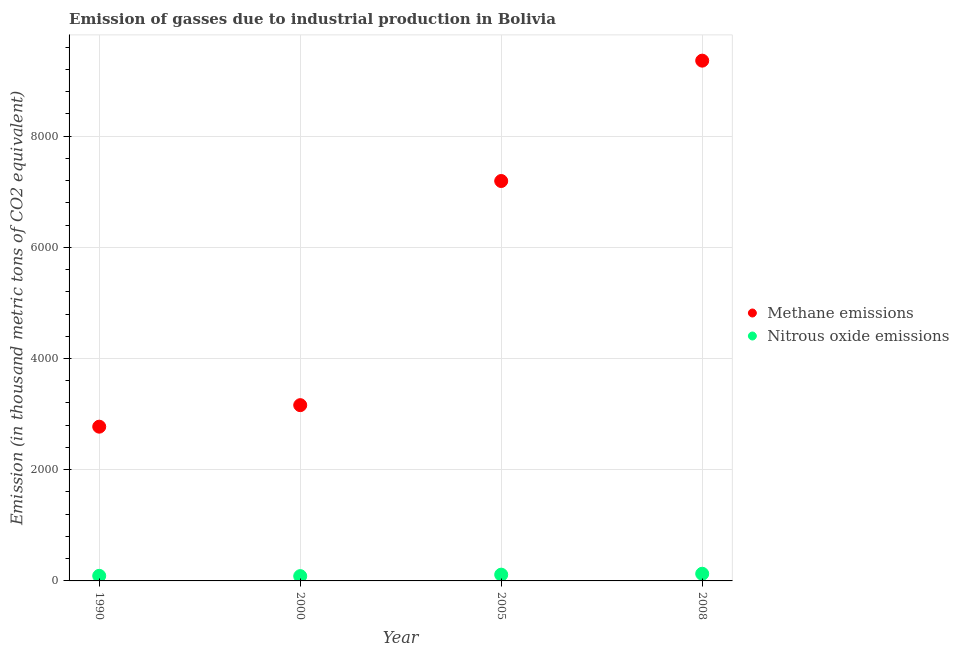What is the amount of methane emissions in 2008?
Provide a short and direct response. 9356.3. Across all years, what is the maximum amount of methane emissions?
Provide a short and direct response. 9356.3. Across all years, what is the minimum amount of methane emissions?
Your answer should be compact. 2773.8. What is the total amount of methane emissions in the graph?
Keep it short and to the point. 2.25e+04. What is the difference between the amount of methane emissions in 1990 and that in 2000?
Provide a succinct answer. -387.1. What is the difference between the amount of nitrous oxide emissions in 2008 and the amount of methane emissions in 2005?
Your response must be concise. -7062.8. What is the average amount of methane emissions per year?
Offer a very short reply. 5620.68. In the year 2005, what is the difference between the amount of methane emissions and amount of nitrous oxide emissions?
Give a very brief answer. 7079. What is the ratio of the amount of methane emissions in 1990 to that in 2008?
Provide a short and direct response. 0.3. Is the difference between the amount of nitrous oxide emissions in 1990 and 2008 greater than the difference between the amount of methane emissions in 1990 and 2008?
Your answer should be very brief. Yes. What is the difference between the highest and the second highest amount of methane emissions?
Provide a succinct answer. 2164.6. What is the difference between the highest and the lowest amount of methane emissions?
Provide a short and direct response. 6582.5. In how many years, is the amount of methane emissions greater than the average amount of methane emissions taken over all years?
Your response must be concise. 2. Is the sum of the amount of methane emissions in 2000 and 2008 greater than the maximum amount of nitrous oxide emissions across all years?
Offer a terse response. Yes. Is the amount of methane emissions strictly greater than the amount of nitrous oxide emissions over the years?
Provide a succinct answer. Yes. Is the amount of methane emissions strictly less than the amount of nitrous oxide emissions over the years?
Provide a succinct answer. No. How many dotlines are there?
Offer a very short reply. 2. What is the difference between two consecutive major ticks on the Y-axis?
Offer a terse response. 2000. What is the title of the graph?
Provide a short and direct response. Emission of gasses due to industrial production in Bolivia. What is the label or title of the X-axis?
Make the answer very short. Year. What is the label or title of the Y-axis?
Your response must be concise. Emission (in thousand metric tons of CO2 equivalent). What is the Emission (in thousand metric tons of CO2 equivalent) in Methane emissions in 1990?
Offer a very short reply. 2773.8. What is the Emission (in thousand metric tons of CO2 equivalent) in Nitrous oxide emissions in 1990?
Your answer should be compact. 91.4. What is the Emission (in thousand metric tons of CO2 equivalent) in Methane emissions in 2000?
Your answer should be very brief. 3160.9. What is the Emission (in thousand metric tons of CO2 equivalent) of Nitrous oxide emissions in 2000?
Your answer should be compact. 86.3. What is the Emission (in thousand metric tons of CO2 equivalent) in Methane emissions in 2005?
Offer a terse response. 7191.7. What is the Emission (in thousand metric tons of CO2 equivalent) in Nitrous oxide emissions in 2005?
Offer a very short reply. 112.7. What is the Emission (in thousand metric tons of CO2 equivalent) of Methane emissions in 2008?
Keep it short and to the point. 9356.3. What is the Emission (in thousand metric tons of CO2 equivalent) in Nitrous oxide emissions in 2008?
Your response must be concise. 128.9. Across all years, what is the maximum Emission (in thousand metric tons of CO2 equivalent) in Methane emissions?
Make the answer very short. 9356.3. Across all years, what is the maximum Emission (in thousand metric tons of CO2 equivalent) in Nitrous oxide emissions?
Your answer should be very brief. 128.9. Across all years, what is the minimum Emission (in thousand metric tons of CO2 equivalent) in Methane emissions?
Offer a terse response. 2773.8. Across all years, what is the minimum Emission (in thousand metric tons of CO2 equivalent) in Nitrous oxide emissions?
Offer a very short reply. 86.3. What is the total Emission (in thousand metric tons of CO2 equivalent) in Methane emissions in the graph?
Provide a succinct answer. 2.25e+04. What is the total Emission (in thousand metric tons of CO2 equivalent) of Nitrous oxide emissions in the graph?
Give a very brief answer. 419.3. What is the difference between the Emission (in thousand metric tons of CO2 equivalent) in Methane emissions in 1990 and that in 2000?
Keep it short and to the point. -387.1. What is the difference between the Emission (in thousand metric tons of CO2 equivalent) in Methane emissions in 1990 and that in 2005?
Your answer should be compact. -4417.9. What is the difference between the Emission (in thousand metric tons of CO2 equivalent) of Nitrous oxide emissions in 1990 and that in 2005?
Make the answer very short. -21.3. What is the difference between the Emission (in thousand metric tons of CO2 equivalent) in Methane emissions in 1990 and that in 2008?
Offer a very short reply. -6582.5. What is the difference between the Emission (in thousand metric tons of CO2 equivalent) of Nitrous oxide emissions in 1990 and that in 2008?
Make the answer very short. -37.5. What is the difference between the Emission (in thousand metric tons of CO2 equivalent) in Methane emissions in 2000 and that in 2005?
Your answer should be very brief. -4030.8. What is the difference between the Emission (in thousand metric tons of CO2 equivalent) of Nitrous oxide emissions in 2000 and that in 2005?
Keep it short and to the point. -26.4. What is the difference between the Emission (in thousand metric tons of CO2 equivalent) in Methane emissions in 2000 and that in 2008?
Offer a very short reply. -6195.4. What is the difference between the Emission (in thousand metric tons of CO2 equivalent) in Nitrous oxide emissions in 2000 and that in 2008?
Offer a terse response. -42.6. What is the difference between the Emission (in thousand metric tons of CO2 equivalent) in Methane emissions in 2005 and that in 2008?
Make the answer very short. -2164.6. What is the difference between the Emission (in thousand metric tons of CO2 equivalent) in Nitrous oxide emissions in 2005 and that in 2008?
Give a very brief answer. -16.2. What is the difference between the Emission (in thousand metric tons of CO2 equivalent) of Methane emissions in 1990 and the Emission (in thousand metric tons of CO2 equivalent) of Nitrous oxide emissions in 2000?
Your answer should be compact. 2687.5. What is the difference between the Emission (in thousand metric tons of CO2 equivalent) in Methane emissions in 1990 and the Emission (in thousand metric tons of CO2 equivalent) in Nitrous oxide emissions in 2005?
Your answer should be very brief. 2661.1. What is the difference between the Emission (in thousand metric tons of CO2 equivalent) of Methane emissions in 1990 and the Emission (in thousand metric tons of CO2 equivalent) of Nitrous oxide emissions in 2008?
Make the answer very short. 2644.9. What is the difference between the Emission (in thousand metric tons of CO2 equivalent) in Methane emissions in 2000 and the Emission (in thousand metric tons of CO2 equivalent) in Nitrous oxide emissions in 2005?
Make the answer very short. 3048.2. What is the difference between the Emission (in thousand metric tons of CO2 equivalent) of Methane emissions in 2000 and the Emission (in thousand metric tons of CO2 equivalent) of Nitrous oxide emissions in 2008?
Keep it short and to the point. 3032. What is the difference between the Emission (in thousand metric tons of CO2 equivalent) in Methane emissions in 2005 and the Emission (in thousand metric tons of CO2 equivalent) in Nitrous oxide emissions in 2008?
Offer a very short reply. 7062.8. What is the average Emission (in thousand metric tons of CO2 equivalent) of Methane emissions per year?
Your answer should be compact. 5620.68. What is the average Emission (in thousand metric tons of CO2 equivalent) of Nitrous oxide emissions per year?
Provide a succinct answer. 104.83. In the year 1990, what is the difference between the Emission (in thousand metric tons of CO2 equivalent) in Methane emissions and Emission (in thousand metric tons of CO2 equivalent) in Nitrous oxide emissions?
Keep it short and to the point. 2682.4. In the year 2000, what is the difference between the Emission (in thousand metric tons of CO2 equivalent) in Methane emissions and Emission (in thousand metric tons of CO2 equivalent) in Nitrous oxide emissions?
Provide a short and direct response. 3074.6. In the year 2005, what is the difference between the Emission (in thousand metric tons of CO2 equivalent) of Methane emissions and Emission (in thousand metric tons of CO2 equivalent) of Nitrous oxide emissions?
Offer a terse response. 7079. In the year 2008, what is the difference between the Emission (in thousand metric tons of CO2 equivalent) in Methane emissions and Emission (in thousand metric tons of CO2 equivalent) in Nitrous oxide emissions?
Keep it short and to the point. 9227.4. What is the ratio of the Emission (in thousand metric tons of CO2 equivalent) in Methane emissions in 1990 to that in 2000?
Offer a very short reply. 0.88. What is the ratio of the Emission (in thousand metric tons of CO2 equivalent) of Nitrous oxide emissions in 1990 to that in 2000?
Your answer should be compact. 1.06. What is the ratio of the Emission (in thousand metric tons of CO2 equivalent) of Methane emissions in 1990 to that in 2005?
Ensure brevity in your answer.  0.39. What is the ratio of the Emission (in thousand metric tons of CO2 equivalent) in Nitrous oxide emissions in 1990 to that in 2005?
Offer a terse response. 0.81. What is the ratio of the Emission (in thousand metric tons of CO2 equivalent) of Methane emissions in 1990 to that in 2008?
Provide a short and direct response. 0.3. What is the ratio of the Emission (in thousand metric tons of CO2 equivalent) of Nitrous oxide emissions in 1990 to that in 2008?
Your response must be concise. 0.71. What is the ratio of the Emission (in thousand metric tons of CO2 equivalent) in Methane emissions in 2000 to that in 2005?
Make the answer very short. 0.44. What is the ratio of the Emission (in thousand metric tons of CO2 equivalent) in Nitrous oxide emissions in 2000 to that in 2005?
Give a very brief answer. 0.77. What is the ratio of the Emission (in thousand metric tons of CO2 equivalent) of Methane emissions in 2000 to that in 2008?
Offer a terse response. 0.34. What is the ratio of the Emission (in thousand metric tons of CO2 equivalent) of Nitrous oxide emissions in 2000 to that in 2008?
Offer a very short reply. 0.67. What is the ratio of the Emission (in thousand metric tons of CO2 equivalent) in Methane emissions in 2005 to that in 2008?
Your answer should be very brief. 0.77. What is the ratio of the Emission (in thousand metric tons of CO2 equivalent) of Nitrous oxide emissions in 2005 to that in 2008?
Your answer should be compact. 0.87. What is the difference between the highest and the second highest Emission (in thousand metric tons of CO2 equivalent) in Methane emissions?
Keep it short and to the point. 2164.6. What is the difference between the highest and the second highest Emission (in thousand metric tons of CO2 equivalent) of Nitrous oxide emissions?
Ensure brevity in your answer.  16.2. What is the difference between the highest and the lowest Emission (in thousand metric tons of CO2 equivalent) of Methane emissions?
Make the answer very short. 6582.5. What is the difference between the highest and the lowest Emission (in thousand metric tons of CO2 equivalent) of Nitrous oxide emissions?
Provide a succinct answer. 42.6. 